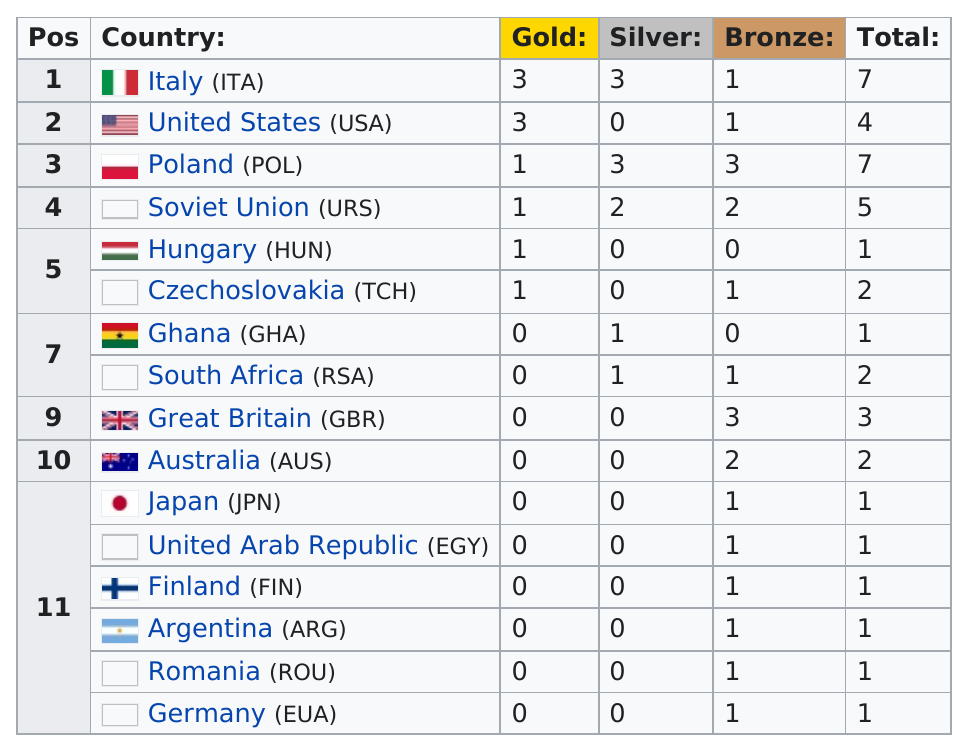Outline some significant characteristics in this image. The total number of boxing medals earned by the top four countries at the 1960 Olympics was 23. The United States, Hungary, Japan, and Ghana all achieved silver medals. Poland won a total of 7 medals in the games. Italy won two more medals than the Soviet Union. The United States placed first in a competition of American countries. 